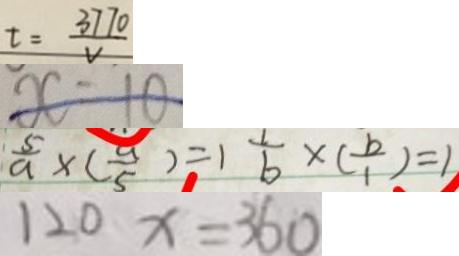<formula> <loc_0><loc_0><loc_500><loc_500>t = \frac { 3 7 7 0 } { v } 
 x = 1 0 
 \frac { 5 } { a } \times ( \frac { a } { 5 } ) = 1 \frac { 1 } { b } \times ( \frac { b } { 1 } ) = 1 
 1 2 0 x = 3 6 0</formula> 